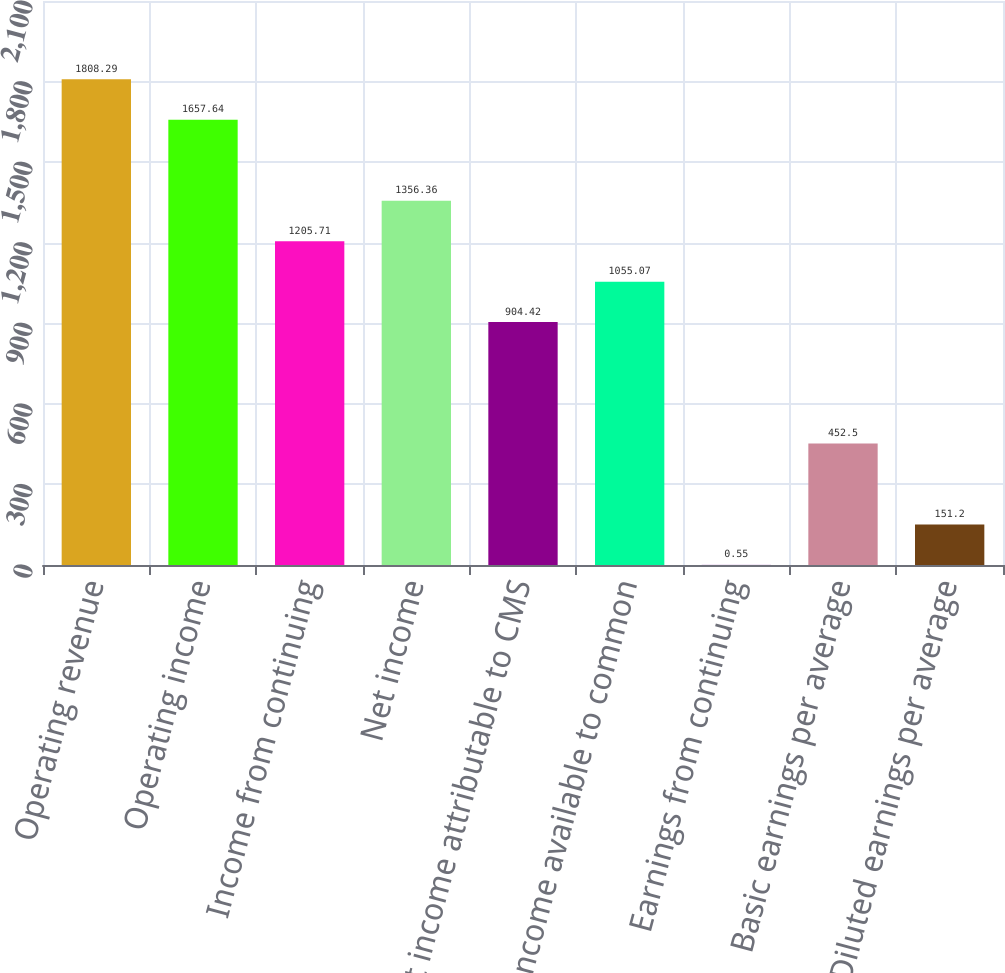<chart> <loc_0><loc_0><loc_500><loc_500><bar_chart><fcel>Operating revenue<fcel>Operating income<fcel>Income from continuing<fcel>Net income<fcel>Net income attributable to CMS<fcel>Net income available to common<fcel>Earnings from continuing<fcel>Basic earnings per average<fcel>Diluted earnings per average<nl><fcel>1808.29<fcel>1657.64<fcel>1205.71<fcel>1356.36<fcel>904.42<fcel>1055.07<fcel>0.55<fcel>452.5<fcel>151.2<nl></chart> 